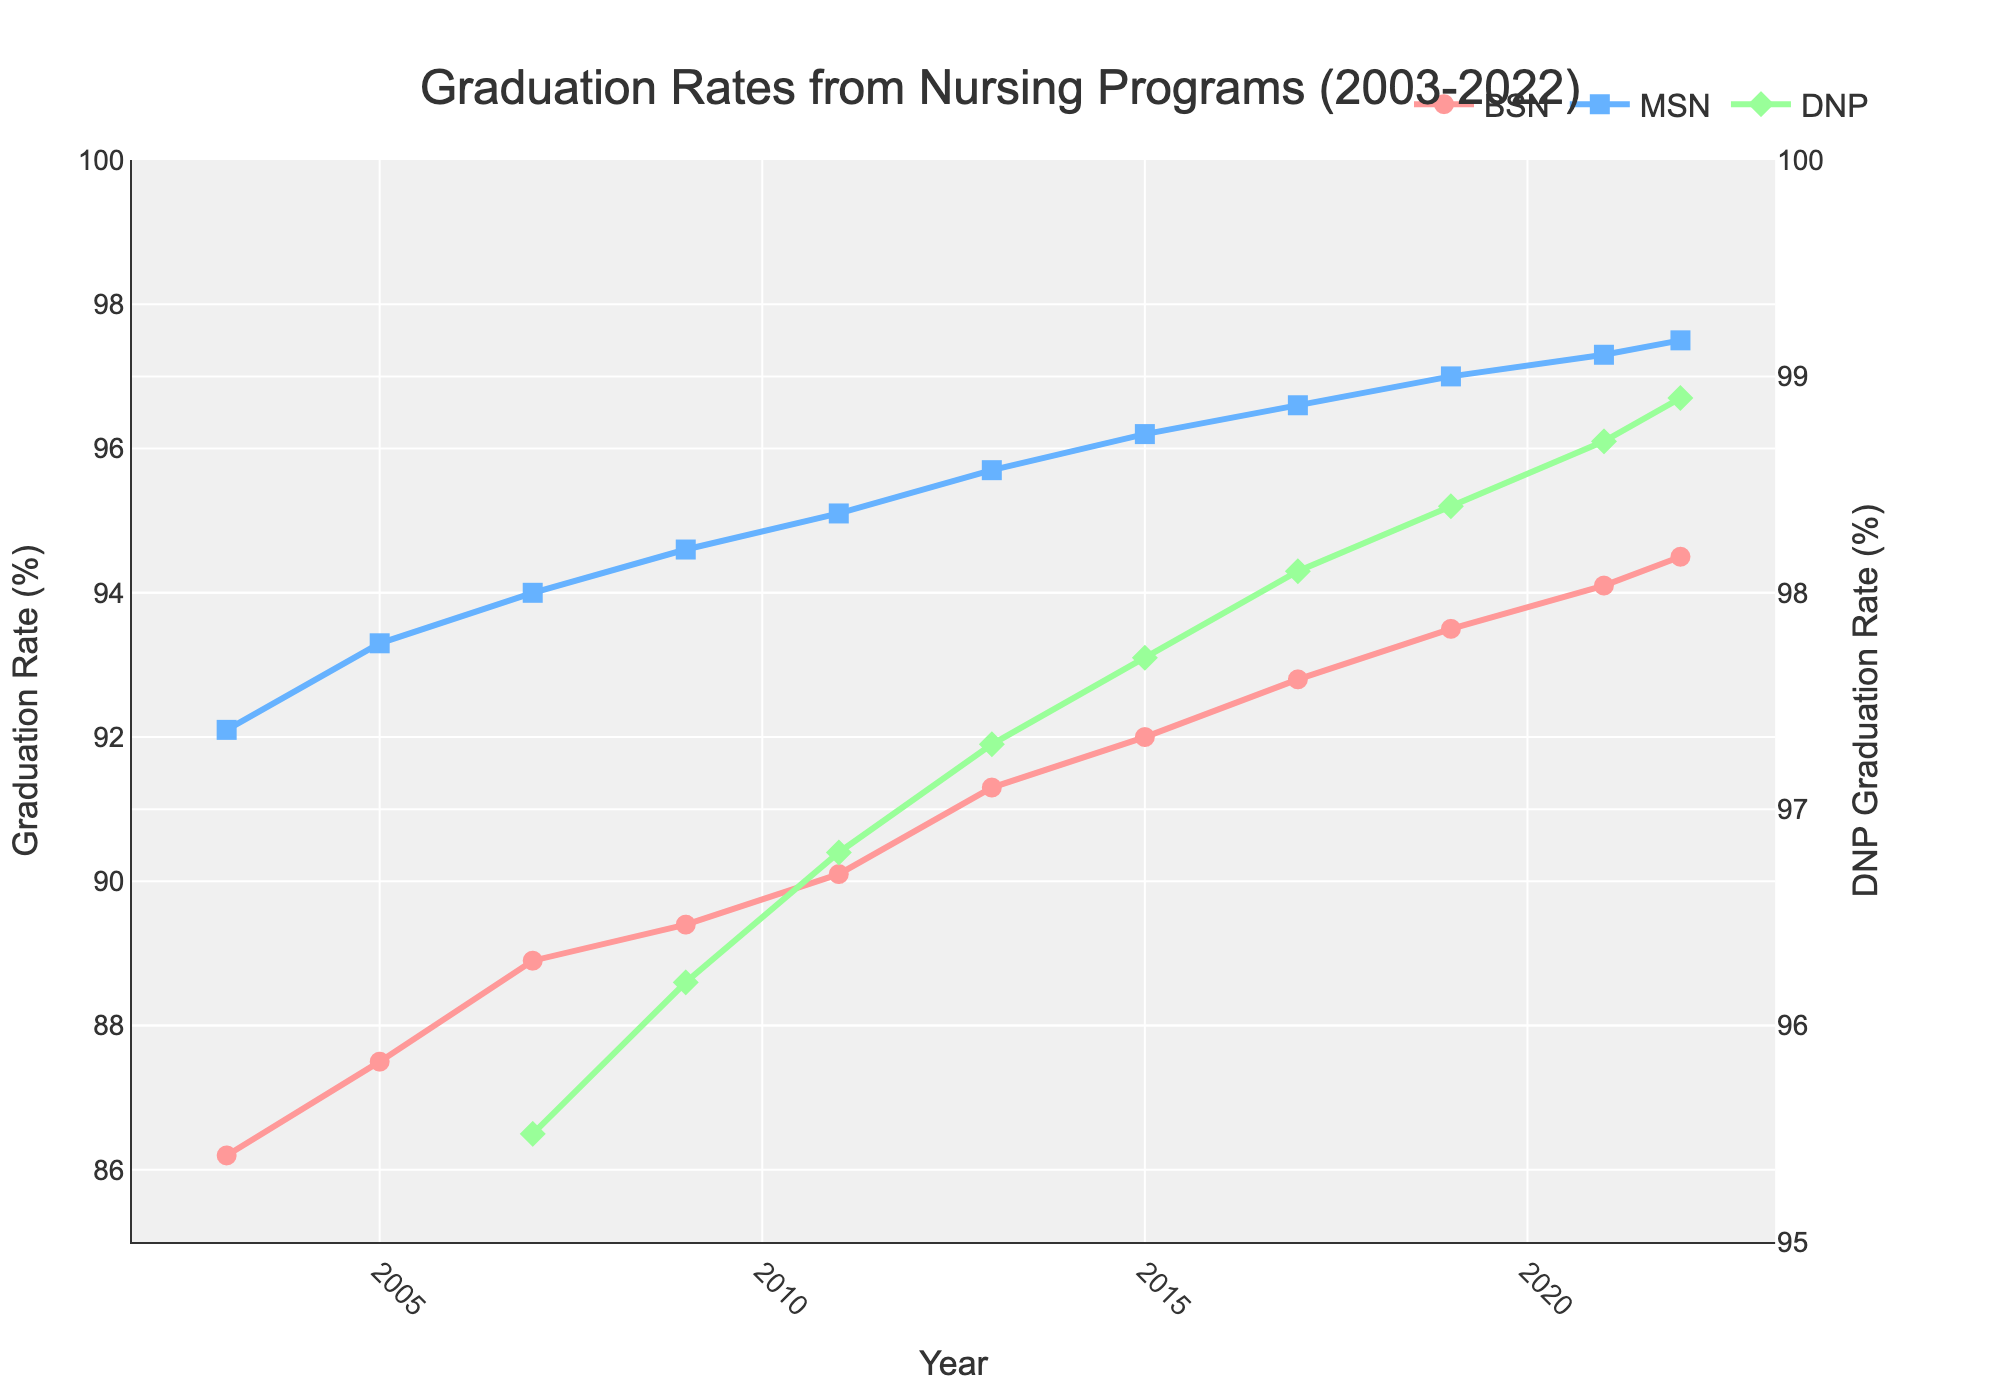What is the graduation rate for BSN in 2022? To find the graduation rate for BSN in 2022, look for the data point associated with the BSN line at the year 2022 on the x-axis.
Answer: 94.5% Which program had the highest graduation rate in 2007? Compare the data points for BSN, MSN, and DNP in the year 2007. The DNP had the highest rate at 95.5%.
Answer: DNP Has the graduation rate for MSN increased or decreased between 2003 and 2022? To determine this, compare the graduation rate for MSN in 2003 with that in 2022. The rate increased from 92.1% to 97.5%.
Answer: Increased What is the average graduation rate for BSN over the 20-year period? Add up the BSN graduation rates from all years provided (86.2 + 87.5 + 88.9 + 89.4 + 90.1 + 91.3 + 92.0 + 92.8 + 93.5 + 94.1 + 94.5) and divide by the number of years (11).
Answer: 90.77% During which year did the graduation rate for DNP achieve 98% or higher? Look for the year(s) on the chart where the DNP graduation rate is at or above 98%. In this case, it's 2017, 2019, 2021, and 2022.
Answer: 2017 Which gradient (slope) appears steeper between 2003-2007 for BSN or 2007-2022 for DNP? Calculate the slopes: for BSN between 2003-2007 it's (88.9 - 86.2)/(2007 - 2003) = 0.675, for DNP between 2007-2022 it's (98.9 - 95.5)/(2022 - 2007) = 0.226. The slope for BSN is steeper.
Answer: BSN In 2021, how does the DNP graduation rate compare to MSN's graduation rate in terms of percentage point difference? Subtract MSN's graduation rate from DNP's graduation rate in 2021 (98.7 - 97.3). The difference is 1.4 percentage points.
Answer: 1.4% Which program shows the most stable graduation rate (least fluctuation) from 2003 to 2022? Assess the visually smallest changes in the lines representing BSN, MSN, and DNP over the given period. The MSN line is the closest to a straight line, indicating the least fluctuation.
Answer: MSN What is the combined graduation rate of BSN and MSN in 2015? Add the graduation rates of BSN and MSN for the year 2015 (92.0 + 96.2).
Answer: 188.2% 